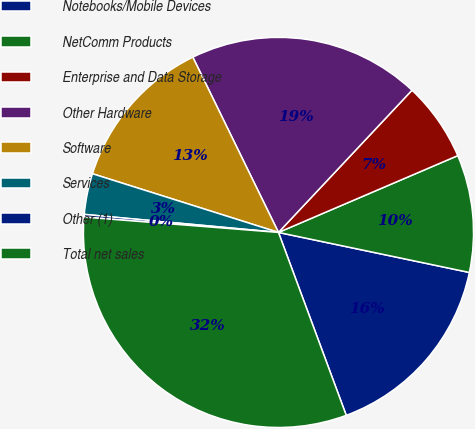Convert chart. <chart><loc_0><loc_0><loc_500><loc_500><pie_chart><fcel>Notebooks/Mobile Devices<fcel>NetComm Products<fcel>Enterprise and Data Storage<fcel>Other Hardware<fcel>Software<fcel>Services<fcel>Other (1)<fcel>Total net sales<nl><fcel>16.06%<fcel>9.73%<fcel>6.56%<fcel>19.23%<fcel>12.9%<fcel>3.39%<fcel>0.22%<fcel>31.9%<nl></chart> 